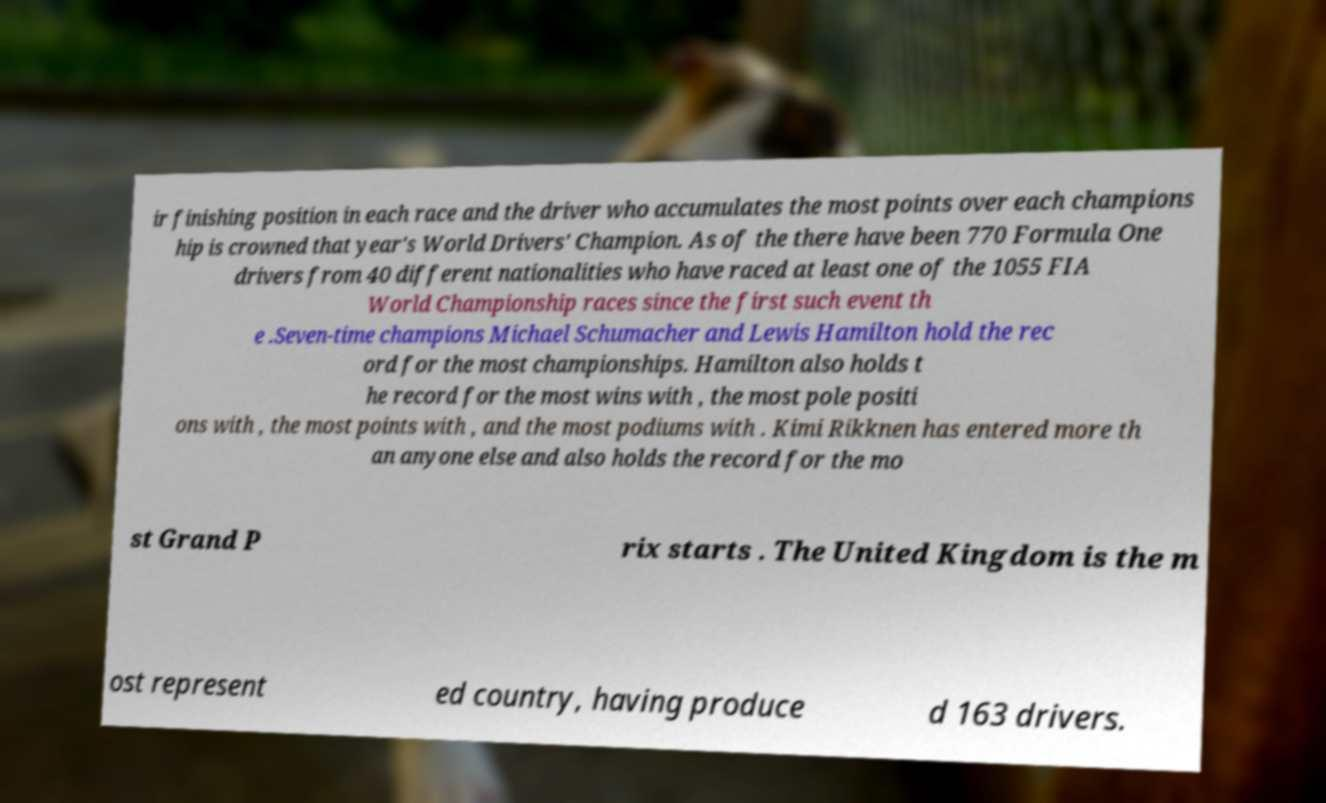Please read and relay the text visible in this image. What does it say? ir finishing position in each race and the driver who accumulates the most points over each champions hip is crowned that year's World Drivers' Champion. As of the there have been 770 Formula One drivers from 40 different nationalities who have raced at least one of the 1055 FIA World Championship races since the first such event th e .Seven-time champions Michael Schumacher and Lewis Hamilton hold the rec ord for the most championships. Hamilton also holds t he record for the most wins with , the most pole positi ons with , the most points with , and the most podiums with . Kimi Rikknen has entered more th an anyone else and also holds the record for the mo st Grand P rix starts . The United Kingdom is the m ost represent ed country, having produce d 163 drivers. 